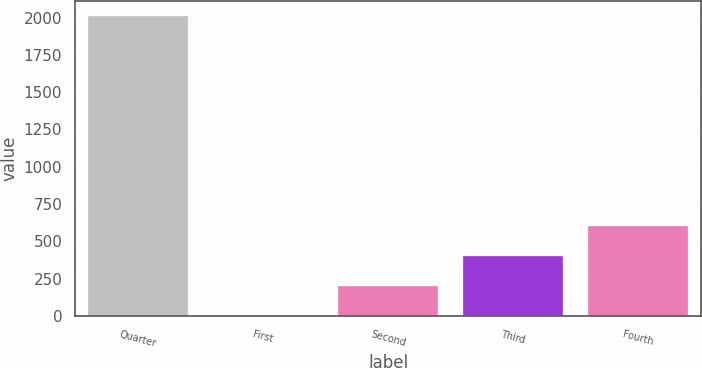<chart> <loc_0><loc_0><loc_500><loc_500><bar_chart><fcel>Quarter<fcel>First<fcel>Second<fcel>Third<fcel>Fourth<nl><fcel>2011<fcel>0.27<fcel>201.34<fcel>402.41<fcel>603.48<nl></chart> 